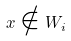<formula> <loc_0><loc_0><loc_500><loc_500>x \notin W _ { i }</formula> 